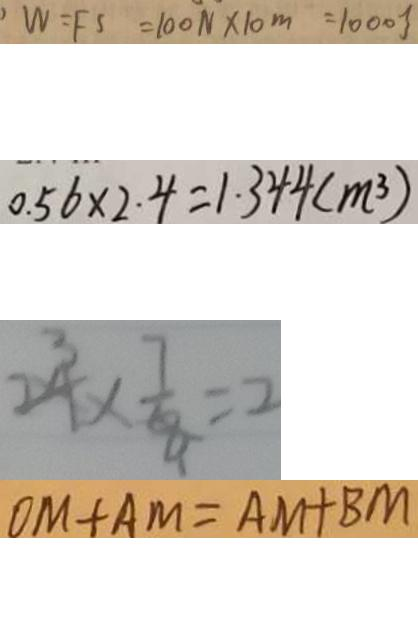<formula> <loc_0><loc_0><loc_500><loc_500>W = F S = 1 0 0 N \times 1 0 m = 1 0 0 0 J 
 0 . 5 6 \times 2 . 4 = 1 . 3 4 4 ( m ^ { 3 } ) 
 2 4 \times \frac { 7 } { 8 } = 2 
 O M + A M = A M + B M</formula> 